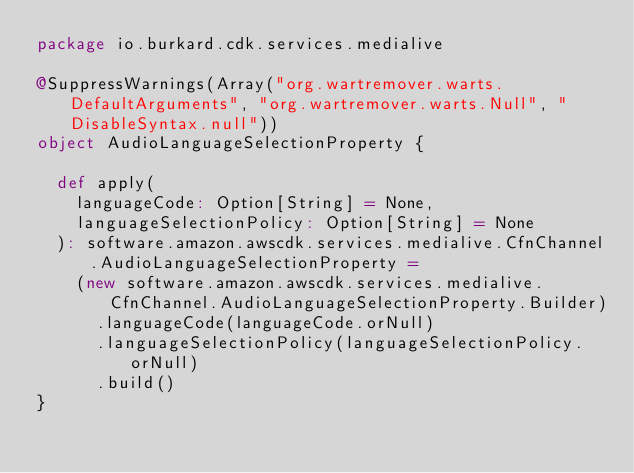Convert code to text. <code><loc_0><loc_0><loc_500><loc_500><_Scala_>package io.burkard.cdk.services.medialive

@SuppressWarnings(Array("org.wartremover.warts.DefaultArguments", "org.wartremover.warts.Null", "DisableSyntax.null"))
object AudioLanguageSelectionProperty {

  def apply(
    languageCode: Option[String] = None,
    languageSelectionPolicy: Option[String] = None
  ): software.amazon.awscdk.services.medialive.CfnChannel.AudioLanguageSelectionProperty =
    (new software.amazon.awscdk.services.medialive.CfnChannel.AudioLanguageSelectionProperty.Builder)
      .languageCode(languageCode.orNull)
      .languageSelectionPolicy(languageSelectionPolicy.orNull)
      .build()
}
</code> 